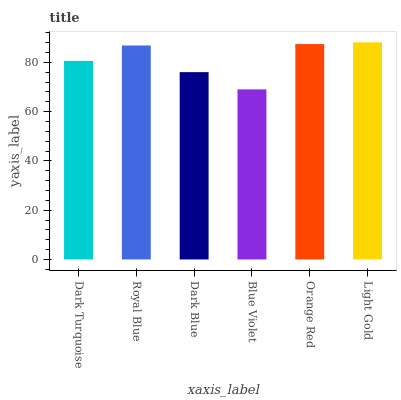Is Blue Violet the minimum?
Answer yes or no. Yes. Is Light Gold the maximum?
Answer yes or no. Yes. Is Royal Blue the minimum?
Answer yes or no. No. Is Royal Blue the maximum?
Answer yes or no. No. Is Royal Blue greater than Dark Turquoise?
Answer yes or no. Yes. Is Dark Turquoise less than Royal Blue?
Answer yes or no. Yes. Is Dark Turquoise greater than Royal Blue?
Answer yes or no. No. Is Royal Blue less than Dark Turquoise?
Answer yes or no. No. Is Royal Blue the high median?
Answer yes or no. Yes. Is Dark Turquoise the low median?
Answer yes or no. Yes. Is Orange Red the high median?
Answer yes or no. No. Is Blue Violet the low median?
Answer yes or no. No. 